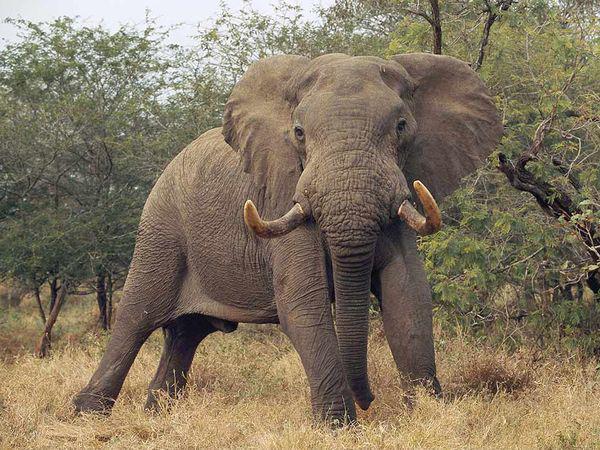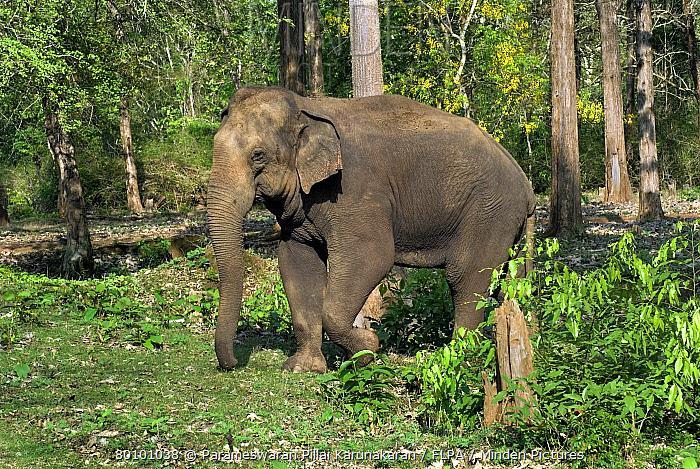The first image is the image on the left, the second image is the image on the right. For the images displayed, is the sentence "Two elephants, an adult and a baby, are walking through a grassy field." factually correct? Answer yes or no. No. The first image is the image on the left, the second image is the image on the right. Assess this claim about the two images: "An image shows an elephant with tusks facing the camera.". Correct or not? Answer yes or no. Yes. 